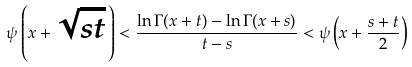<formula> <loc_0><loc_0><loc_500><loc_500>\psi \left ( x + \sqrt { s t } \, \right ) < \frac { \ln \Gamma ( x + t ) - \ln \Gamma ( x + s ) } { t - s } < \psi \left ( x + \frac { s + t } 2 \right )</formula> 